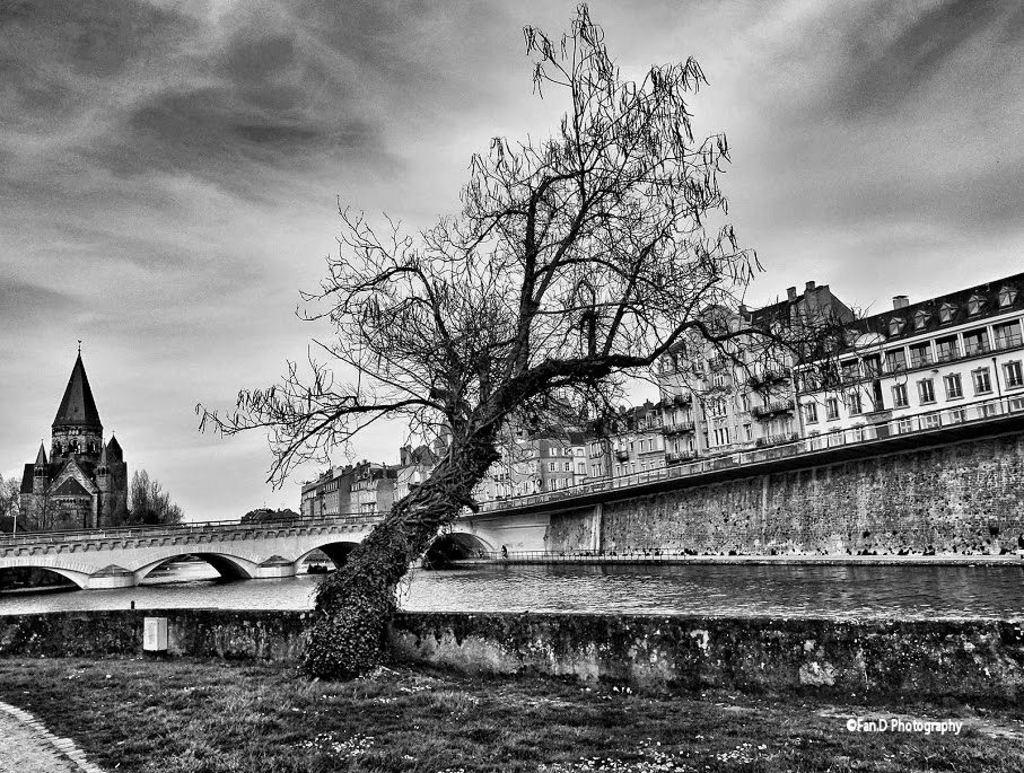What type of structures can be seen in the image? There are buildings in the image. What other natural elements are present in the image? There are trees in the image. What feature can be found on the buildings and possibly other structures? There are windows in the image. What body of water is visible in the image? There is water visible in the image. What type of man-made structure is present in the image? There is a bridge in the image. What color scheme is used in the image? The image is in black and white color. What type of rice is being served on the gold plate in the image? There is no rice or gold plate present in the image; it features buildings, trees, windows, water, and a bridge in black and white color. What is the tendency of the water in the image? The image does not depict the water's movement or behavior, so it is not possible to determine its tendency. 